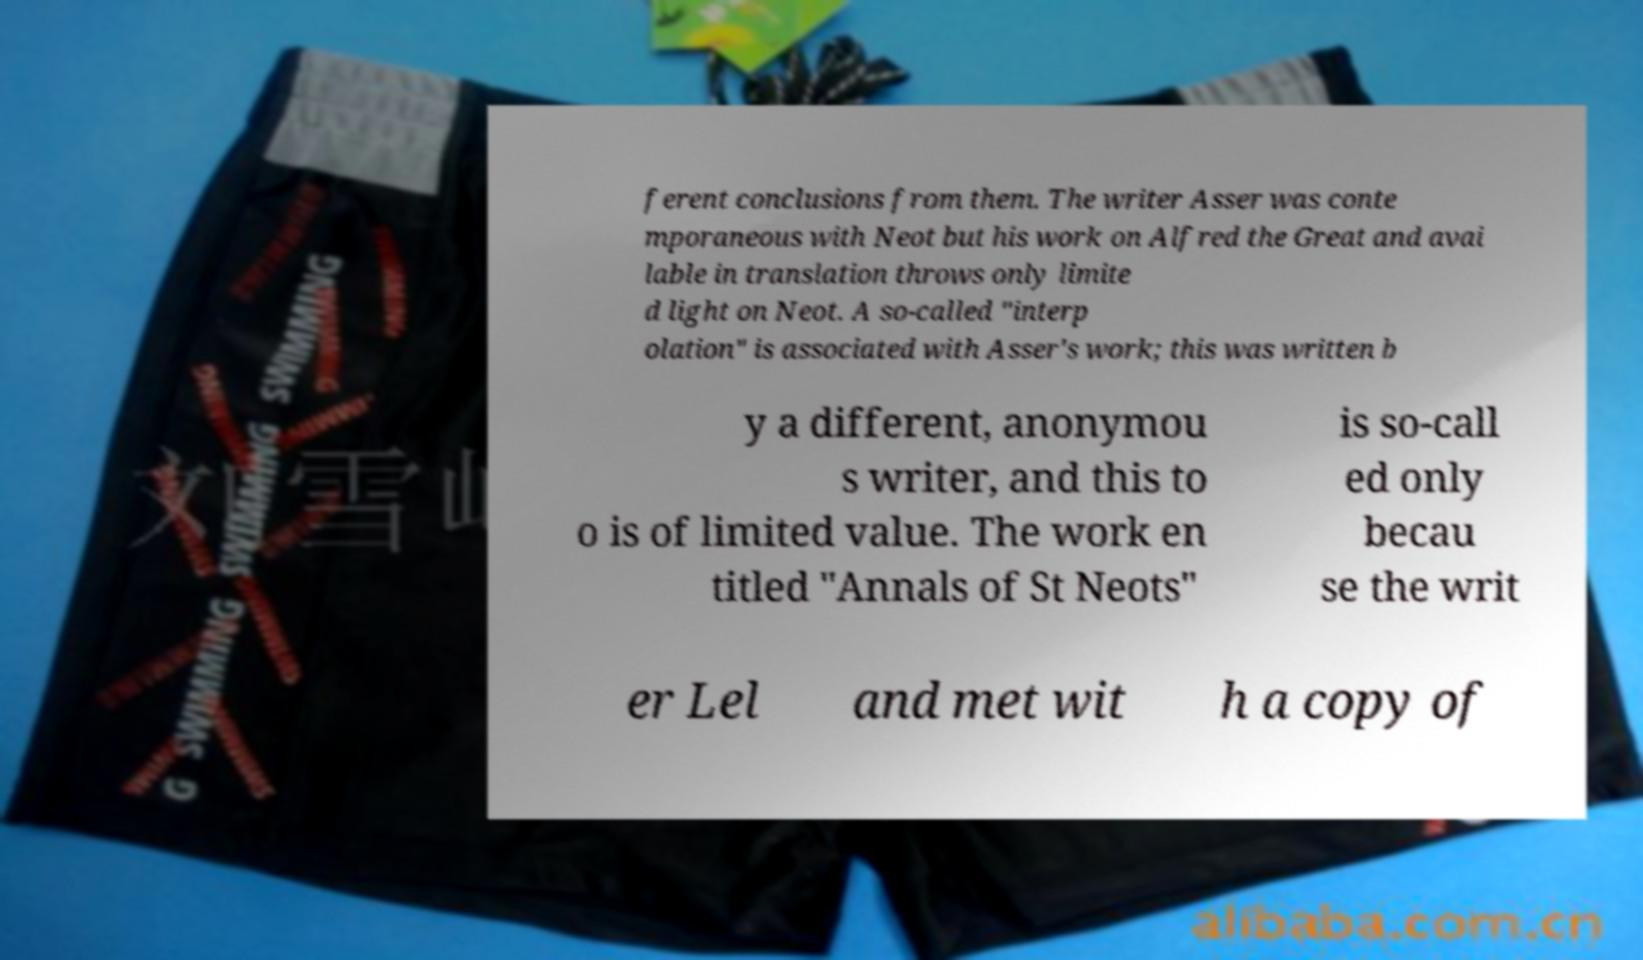Can you accurately transcribe the text from the provided image for me? ferent conclusions from them. The writer Asser was conte mporaneous with Neot but his work on Alfred the Great and avai lable in translation throws only limite d light on Neot. A so-called "interp olation" is associated with Asser's work; this was written b y a different, anonymou s writer, and this to o is of limited value. The work en titled "Annals of St Neots" is so-call ed only becau se the writ er Lel and met wit h a copy of 